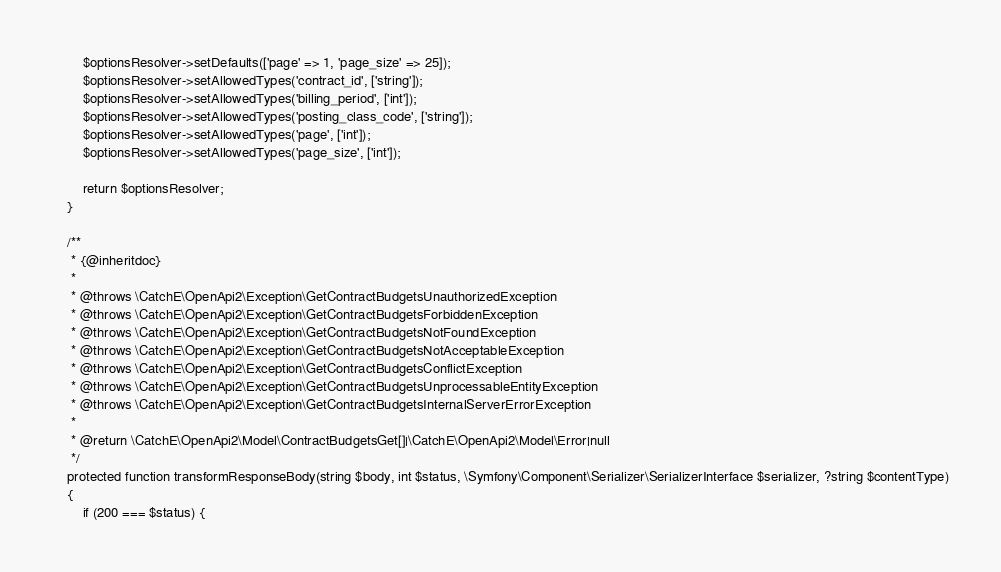Convert code to text. <code><loc_0><loc_0><loc_500><loc_500><_PHP_>		$optionsResolver->setDefaults(['page' => 1, 'page_size' => 25]);
		$optionsResolver->setAllowedTypes('contract_id', ['string']);
		$optionsResolver->setAllowedTypes('billing_period', ['int']);
		$optionsResolver->setAllowedTypes('posting_class_code', ['string']);
		$optionsResolver->setAllowedTypes('page', ['int']);
		$optionsResolver->setAllowedTypes('page_size', ['int']);

		return $optionsResolver;
	}

	/**
	 * {@inheritdoc}
	 *
	 * @throws \CatchE\OpenApi2\Exception\GetContractBudgetsUnauthorizedException
	 * @throws \CatchE\OpenApi2\Exception\GetContractBudgetsForbiddenException
	 * @throws \CatchE\OpenApi2\Exception\GetContractBudgetsNotFoundException
	 * @throws \CatchE\OpenApi2\Exception\GetContractBudgetsNotAcceptableException
	 * @throws \CatchE\OpenApi2\Exception\GetContractBudgetsConflictException
	 * @throws \CatchE\OpenApi2\Exception\GetContractBudgetsUnprocessableEntityException
	 * @throws \CatchE\OpenApi2\Exception\GetContractBudgetsInternalServerErrorException
	 *
	 * @return \CatchE\OpenApi2\Model\ContractBudgetsGet[]|\CatchE\OpenApi2\Model\Error|null
	 */
	protected function transformResponseBody(string $body, int $status, \Symfony\Component\Serializer\SerializerInterface $serializer, ?string $contentType)
	{
		if (200 === $status) {</code> 